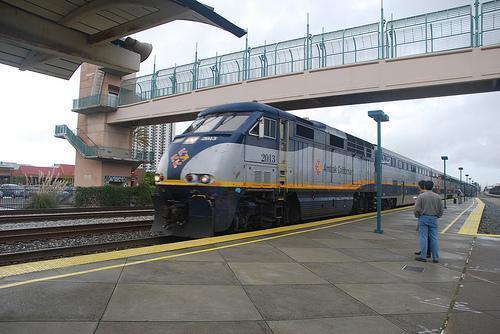How many trains are in the photo?
Give a very brief answer. 1. 